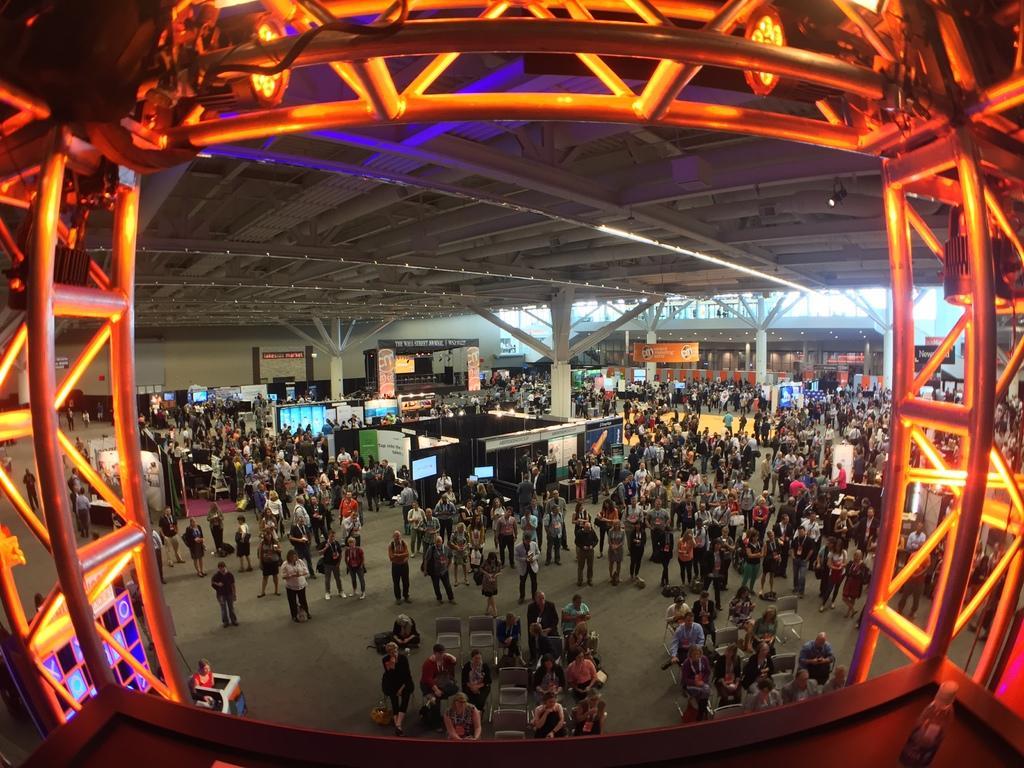Could you give a brief overview of what you see in this image? In this picture we can see a bottle, rods, lights and some people are sitting on chairs and a group of people are standing on the floor and in the background we can see pillars, posters, wall, roof and some objects. 